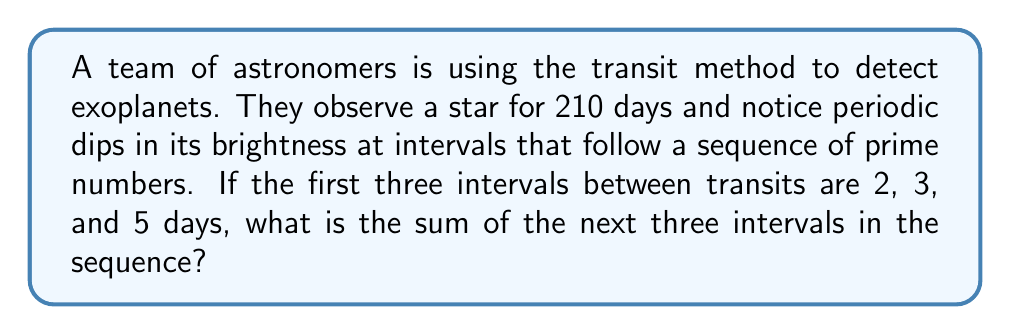Show me your answer to this math problem. Let's approach this step-by-step:

1) The sequence of intervals follows prime numbers. We're given the first three: 2, 3, and 5.

2) The next three prime numbers in the sequence would be 7, 11, and 13.

3) To find the sum of these next three intervals, we simply add them:

   $$7 + 11 + 13 = 31$$

4) We can verify that this sequence fits within the 210-day observation period:

   $$2 + 3 + 5 + 7 + 11 + 13 = 41$$

   The sum of all six intervals is 41 days, which is less than the total observation period of 210 days.

5) Therefore, the sum of the next three intervals in the prime number sequence is 31 days.

This sequence could indicate a complex multi-planet system where each planet's orbital period corresponds to a prime number of days, a fascinating scenario for our Italian physics teacher interested in space studies.
Answer: 31 days 